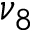Convert formula to latex. <formula><loc_0><loc_0><loc_500><loc_500>\nu _ { 8 }</formula> 